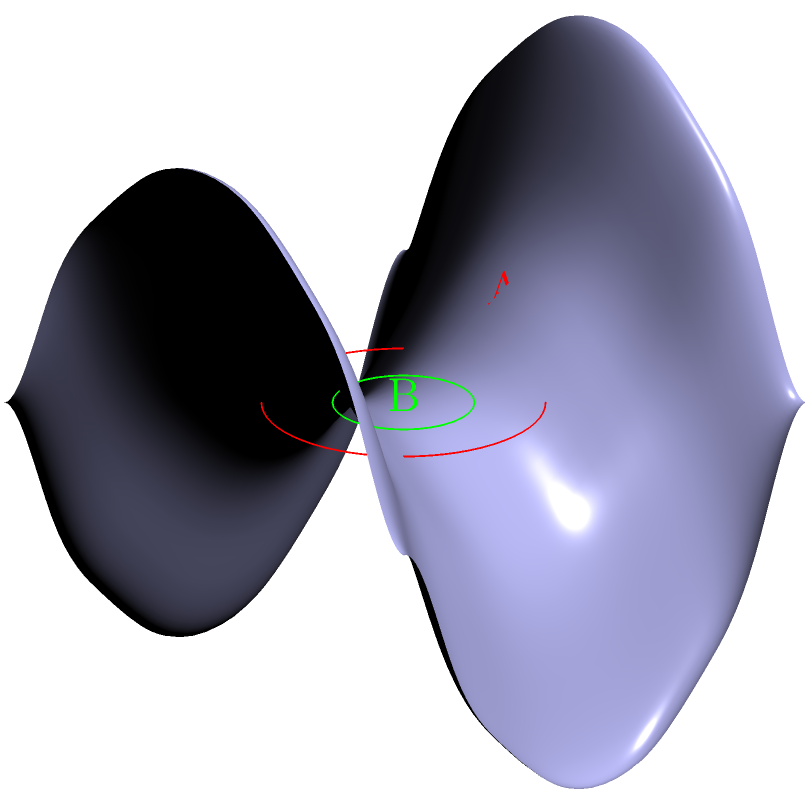In the context of non-Euclidean geometry on a saddle-shaped surface, as shown in the diagram, how would the circumference-to-radius ratio of circle A compare to that of circle B? Consider how this might relate to the concept of space distortion in a daycare setting. To understand this concept, let's break it down step-by-step:

1. In Euclidean geometry, the ratio of a circle's circumference to its radius is always $2\pi$, regardless of the circle's size.

2. However, on a saddle-shaped surface (hyperbolic geometry):
   a) The curvature varies at different points on the surface.
   b) This varying curvature affects the behavior of circles drawn on the surface.

3. Circle A:
   a) Located near the center of the saddle.
   b) The surface curves more sharply here.
   c) This causes the circle to "spread out" more than it would on a flat surface.

4. Circle B:
   a) Located farther from the center, where the surface is flatter.
   b) The circle behaves more like it would in Euclidean geometry.

5. Comparison:
   a) Circle A will have a larger circumference-to-radius ratio than $2\pi$.
   b) Circle B will have a ratio closer to $2\pi$, but still slightly larger.

6. Relating to a daycare setting:
   This concept can be likened to how children's behavior might "spread out" differently in various areas of a daycare. In tighter, more structured spaces (like circle B), behavior might be more predictable and "Euclidean." In open, less structured areas (like circle A), behavior might "spread out" more, requiring different management strategies.
Answer: Circle A's circumference-to-radius ratio > Circle B's ratio > $2\pi$ 